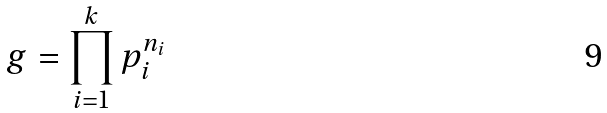<formula> <loc_0><loc_0><loc_500><loc_500>g = \prod _ { i = 1 } ^ { k } p _ { i } ^ { n _ { i } }</formula> 